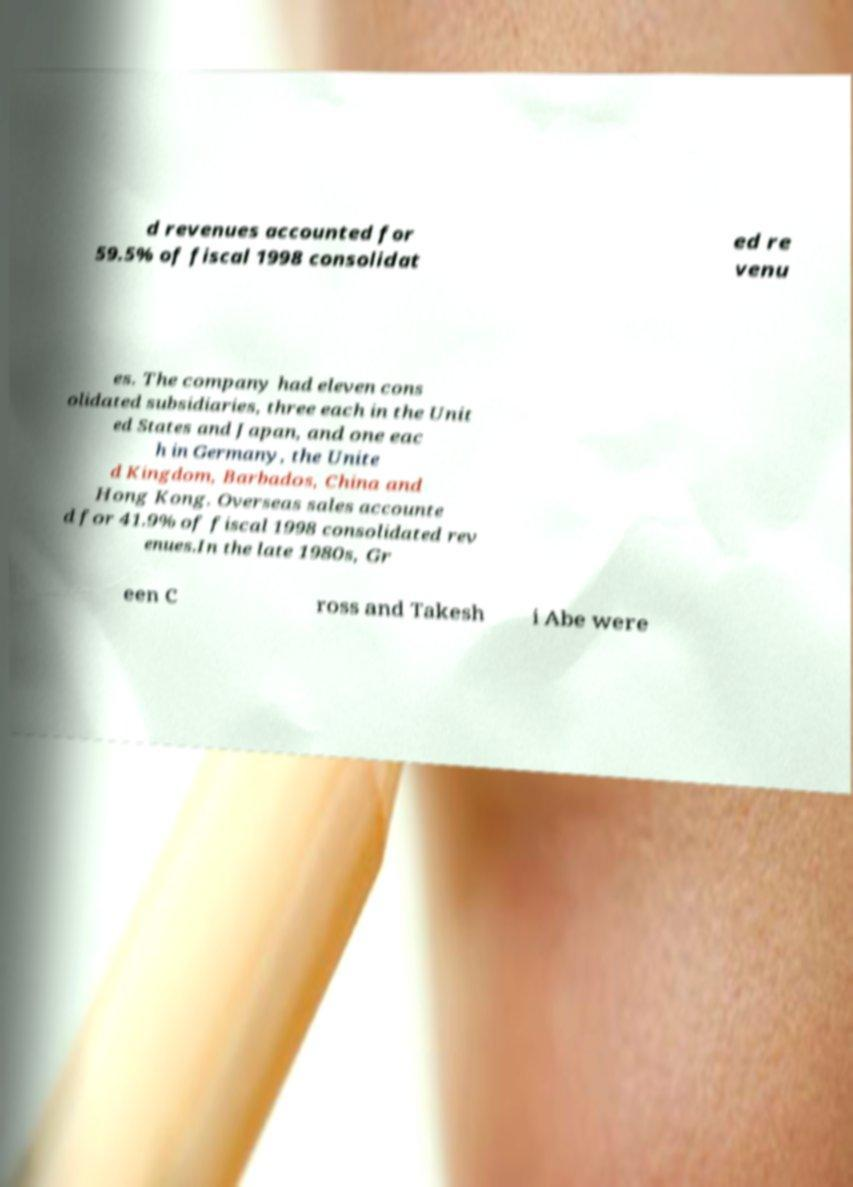Could you extract and type out the text from this image? d revenues accounted for 59.5% of fiscal 1998 consolidat ed re venu es. The company had eleven cons olidated subsidiaries, three each in the Unit ed States and Japan, and one eac h in Germany, the Unite d Kingdom, Barbados, China and Hong Kong. Overseas sales accounte d for 41.9% of fiscal 1998 consolidated rev enues.In the late 1980s, Gr een C ross and Takesh i Abe were 